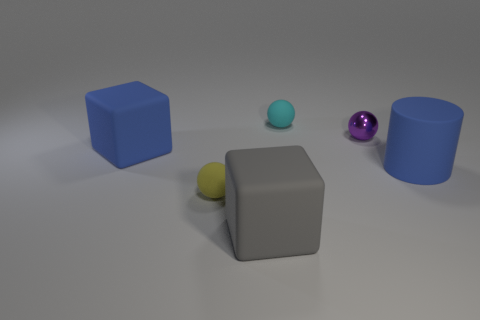Add 4 cyan metallic spheres. How many objects exist? 10 Subtract all cylinders. How many objects are left? 5 Subtract 0 purple cylinders. How many objects are left? 6 Subtract all tiny purple metallic objects. Subtract all tiny purple objects. How many objects are left? 4 Add 5 cyan things. How many cyan things are left? 6 Add 3 blue objects. How many blue objects exist? 5 